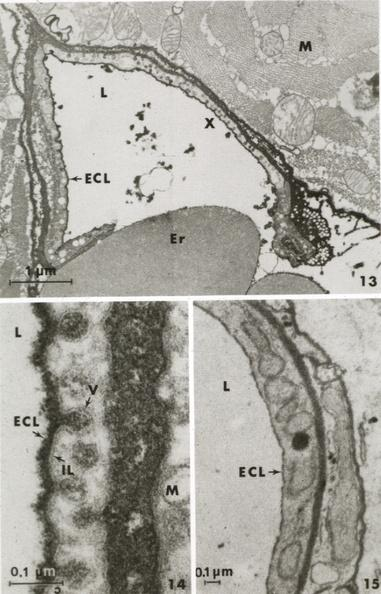s capillary present?
Answer the question using a single word or phrase. Yes 